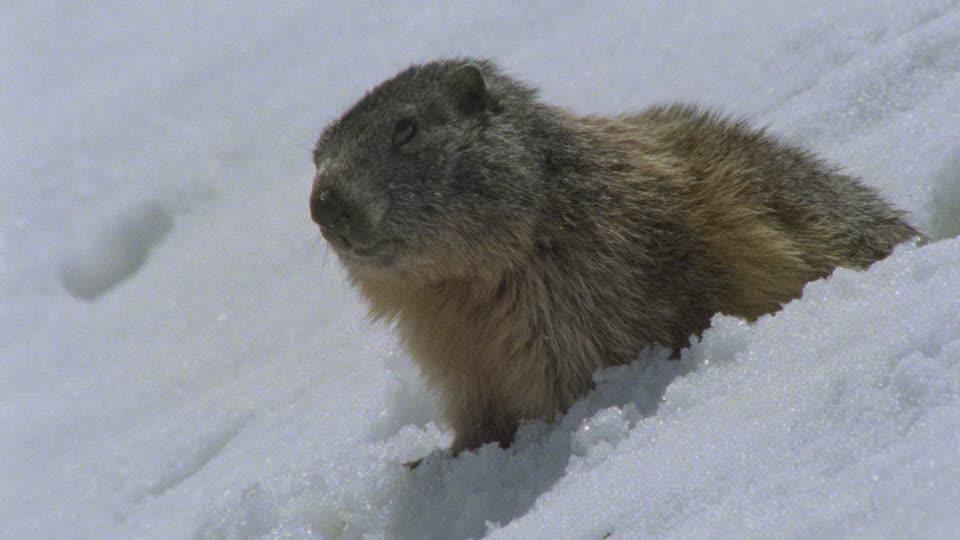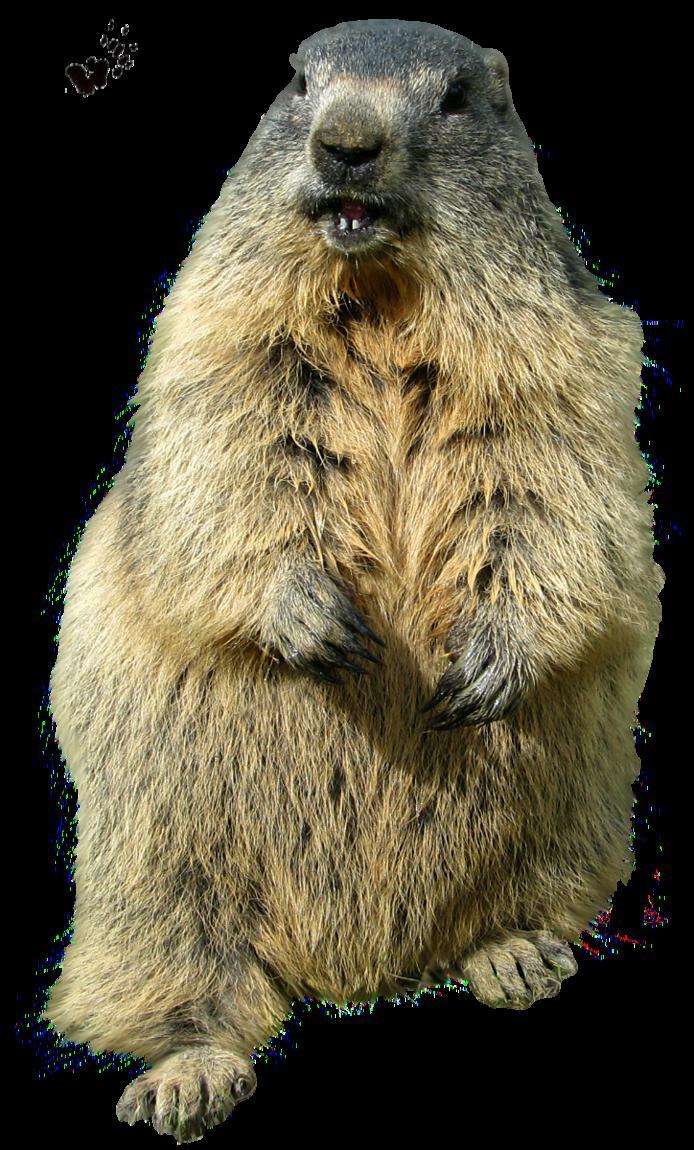The first image is the image on the left, the second image is the image on the right. For the images displayed, is the sentence "One animal is in the snow in the image on the left." factually correct? Answer yes or no. Yes. The first image is the image on the left, the second image is the image on the right. Given the left and right images, does the statement "One image contains twice as many marmots as the other image." hold true? Answer yes or no. No. 